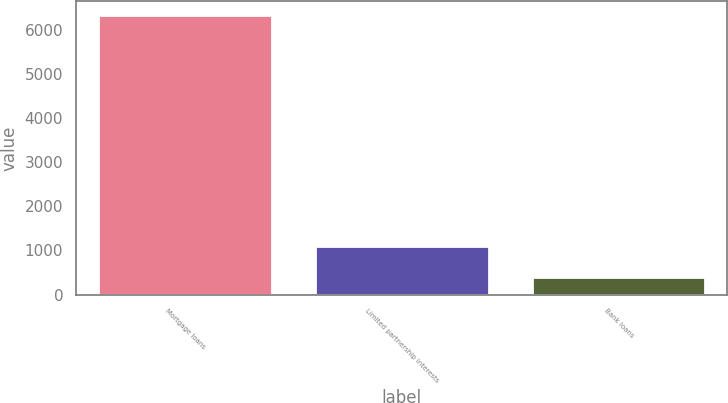<chart> <loc_0><loc_0><loc_500><loc_500><bar_chart><fcel>Mortgage loans<fcel>Limited partnership interests<fcel>Bank loans<nl><fcel>6336<fcel>1098<fcel>391<nl></chart> 